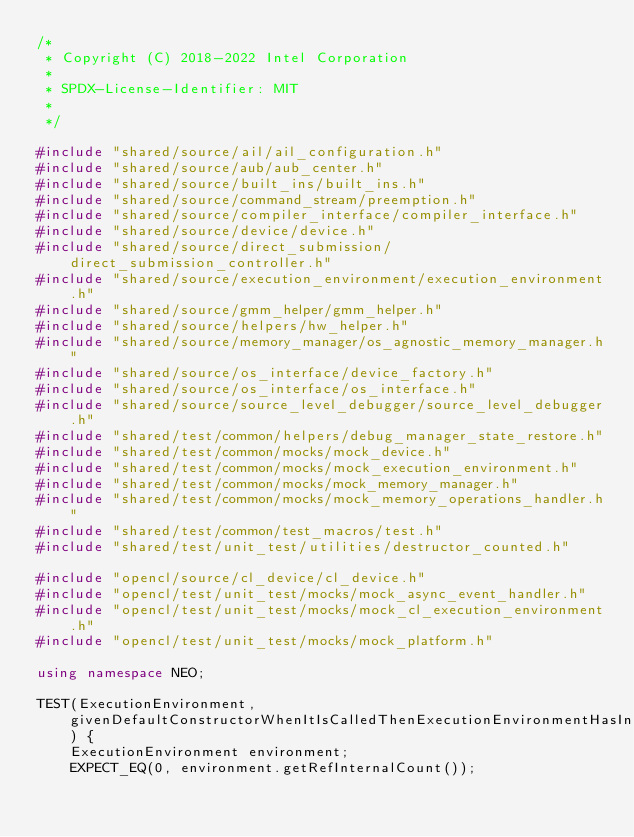<code> <loc_0><loc_0><loc_500><loc_500><_C++_>/*
 * Copyright (C) 2018-2022 Intel Corporation
 *
 * SPDX-License-Identifier: MIT
 *
 */

#include "shared/source/ail/ail_configuration.h"
#include "shared/source/aub/aub_center.h"
#include "shared/source/built_ins/built_ins.h"
#include "shared/source/command_stream/preemption.h"
#include "shared/source/compiler_interface/compiler_interface.h"
#include "shared/source/device/device.h"
#include "shared/source/direct_submission/direct_submission_controller.h"
#include "shared/source/execution_environment/execution_environment.h"
#include "shared/source/gmm_helper/gmm_helper.h"
#include "shared/source/helpers/hw_helper.h"
#include "shared/source/memory_manager/os_agnostic_memory_manager.h"
#include "shared/source/os_interface/device_factory.h"
#include "shared/source/os_interface/os_interface.h"
#include "shared/source/source_level_debugger/source_level_debugger.h"
#include "shared/test/common/helpers/debug_manager_state_restore.h"
#include "shared/test/common/mocks/mock_device.h"
#include "shared/test/common/mocks/mock_execution_environment.h"
#include "shared/test/common/mocks/mock_memory_manager.h"
#include "shared/test/common/mocks/mock_memory_operations_handler.h"
#include "shared/test/common/test_macros/test.h"
#include "shared/test/unit_test/utilities/destructor_counted.h"

#include "opencl/source/cl_device/cl_device.h"
#include "opencl/test/unit_test/mocks/mock_async_event_handler.h"
#include "opencl/test/unit_test/mocks/mock_cl_execution_environment.h"
#include "opencl/test/unit_test/mocks/mock_platform.h"

using namespace NEO;

TEST(ExecutionEnvironment, givenDefaultConstructorWhenItIsCalledThenExecutionEnvironmentHasInitialRefCountZero) {
    ExecutionEnvironment environment;
    EXPECT_EQ(0, environment.getRefInternalCount());</code> 